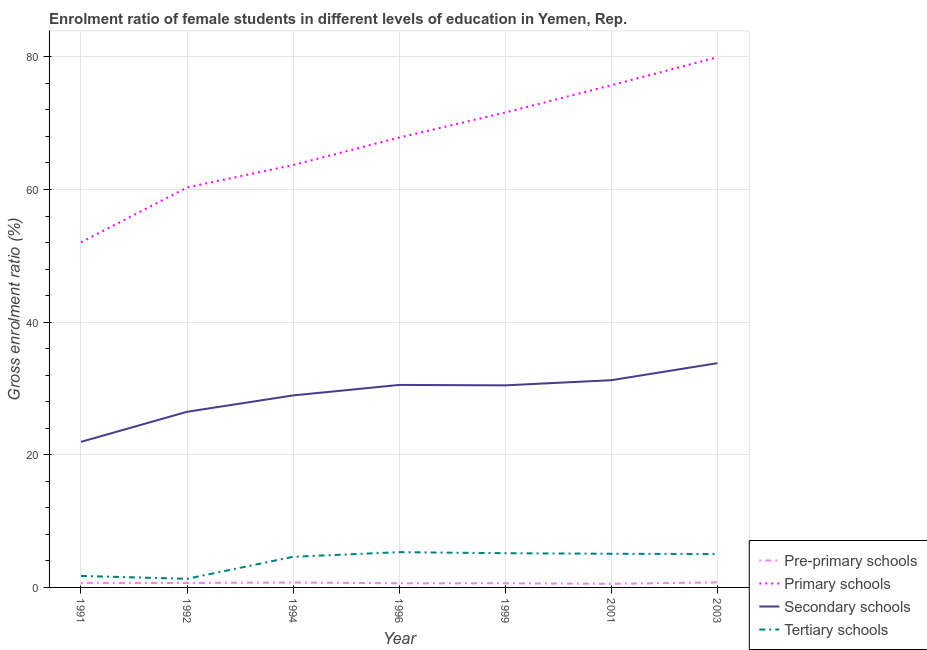Is the number of lines equal to the number of legend labels?
Your answer should be very brief. Yes. What is the gross enrolment ratio(male) in pre-primary schools in 2003?
Ensure brevity in your answer.  0.76. Across all years, what is the maximum gross enrolment ratio(male) in pre-primary schools?
Provide a short and direct response. 0.76. Across all years, what is the minimum gross enrolment ratio(male) in secondary schools?
Offer a terse response. 21.95. In which year was the gross enrolment ratio(male) in secondary schools maximum?
Give a very brief answer. 2003. What is the total gross enrolment ratio(male) in secondary schools in the graph?
Ensure brevity in your answer.  203.45. What is the difference between the gross enrolment ratio(male) in primary schools in 1999 and that in 2001?
Make the answer very short. -4.11. What is the difference between the gross enrolment ratio(male) in tertiary schools in 1999 and the gross enrolment ratio(male) in pre-primary schools in 1996?
Provide a succinct answer. 4.54. What is the average gross enrolment ratio(male) in secondary schools per year?
Offer a terse response. 29.06. In the year 2003, what is the difference between the gross enrolment ratio(male) in pre-primary schools and gross enrolment ratio(male) in primary schools?
Your answer should be compact. -79.19. In how many years, is the gross enrolment ratio(male) in pre-primary schools greater than 20 %?
Your answer should be very brief. 0. What is the ratio of the gross enrolment ratio(male) in tertiary schools in 1992 to that in 1999?
Give a very brief answer. 0.25. Is the difference between the gross enrolment ratio(male) in primary schools in 1996 and 2003 greater than the difference between the gross enrolment ratio(male) in secondary schools in 1996 and 2003?
Provide a succinct answer. No. What is the difference between the highest and the second highest gross enrolment ratio(male) in pre-primary schools?
Your response must be concise. 0.02. What is the difference between the highest and the lowest gross enrolment ratio(male) in tertiary schools?
Offer a very short reply. 4.02. Is the sum of the gross enrolment ratio(male) in pre-primary schools in 2001 and 2003 greater than the maximum gross enrolment ratio(male) in primary schools across all years?
Make the answer very short. No. Is it the case that in every year, the sum of the gross enrolment ratio(male) in secondary schools and gross enrolment ratio(male) in tertiary schools is greater than the sum of gross enrolment ratio(male) in primary schools and gross enrolment ratio(male) in pre-primary schools?
Give a very brief answer. No. Is it the case that in every year, the sum of the gross enrolment ratio(male) in pre-primary schools and gross enrolment ratio(male) in primary schools is greater than the gross enrolment ratio(male) in secondary schools?
Provide a succinct answer. Yes. Is the gross enrolment ratio(male) in primary schools strictly greater than the gross enrolment ratio(male) in secondary schools over the years?
Your response must be concise. Yes. Is the gross enrolment ratio(male) in tertiary schools strictly less than the gross enrolment ratio(male) in pre-primary schools over the years?
Your answer should be compact. No. What is the difference between two consecutive major ticks on the Y-axis?
Make the answer very short. 20. Does the graph contain any zero values?
Make the answer very short. No. Does the graph contain grids?
Offer a very short reply. Yes. Where does the legend appear in the graph?
Your answer should be very brief. Bottom right. How many legend labels are there?
Your answer should be compact. 4. How are the legend labels stacked?
Your answer should be very brief. Vertical. What is the title of the graph?
Make the answer very short. Enrolment ratio of female students in different levels of education in Yemen, Rep. What is the label or title of the X-axis?
Ensure brevity in your answer.  Year. What is the label or title of the Y-axis?
Provide a succinct answer. Gross enrolment ratio (%). What is the Gross enrolment ratio (%) in Pre-primary schools in 1991?
Offer a terse response. 0.68. What is the Gross enrolment ratio (%) in Primary schools in 1991?
Offer a terse response. 52.03. What is the Gross enrolment ratio (%) in Secondary schools in 1991?
Your response must be concise. 21.95. What is the Gross enrolment ratio (%) of Tertiary schools in 1991?
Your response must be concise. 1.73. What is the Gross enrolment ratio (%) in Pre-primary schools in 1992?
Give a very brief answer. 0.67. What is the Gross enrolment ratio (%) in Primary schools in 1992?
Provide a succinct answer. 60.31. What is the Gross enrolment ratio (%) in Secondary schools in 1992?
Keep it short and to the point. 26.48. What is the Gross enrolment ratio (%) of Tertiary schools in 1992?
Offer a very short reply. 1.3. What is the Gross enrolment ratio (%) of Pre-primary schools in 1994?
Offer a terse response. 0.74. What is the Gross enrolment ratio (%) of Primary schools in 1994?
Your answer should be compact. 63.69. What is the Gross enrolment ratio (%) of Secondary schools in 1994?
Your response must be concise. 28.95. What is the Gross enrolment ratio (%) in Tertiary schools in 1994?
Ensure brevity in your answer.  4.62. What is the Gross enrolment ratio (%) of Pre-primary schools in 1996?
Ensure brevity in your answer.  0.62. What is the Gross enrolment ratio (%) of Primary schools in 1996?
Your answer should be compact. 67.84. What is the Gross enrolment ratio (%) in Secondary schools in 1996?
Your response must be concise. 30.53. What is the Gross enrolment ratio (%) of Tertiary schools in 1996?
Offer a terse response. 5.32. What is the Gross enrolment ratio (%) of Pre-primary schools in 1999?
Keep it short and to the point. 0.63. What is the Gross enrolment ratio (%) in Primary schools in 1999?
Make the answer very short. 71.61. What is the Gross enrolment ratio (%) in Secondary schools in 1999?
Provide a succinct answer. 30.47. What is the Gross enrolment ratio (%) of Tertiary schools in 1999?
Ensure brevity in your answer.  5.16. What is the Gross enrolment ratio (%) of Pre-primary schools in 2001?
Offer a terse response. 0.55. What is the Gross enrolment ratio (%) of Primary schools in 2001?
Give a very brief answer. 75.72. What is the Gross enrolment ratio (%) of Secondary schools in 2001?
Give a very brief answer. 31.25. What is the Gross enrolment ratio (%) in Tertiary schools in 2001?
Your answer should be very brief. 5.07. What is the Gross enrolment ratio (%) of Pre-primary schools in 2003?
Provide a succinct answer. 0.76. What is the Gross enrolment ratio (%) of Primary schools in 2003?
Give a very brief answer. 79.96. What is the Gross enrolment ratio (%) of Secondary schools in 2003?
Provide a short and direct response. 33.82. What is the Gross enrolment ratio (%) of Tertiary schools in 2003?
Ensure brevity in your answer.  5.03. Across all years, what is the maximum Gross enrolment ratio (%) of Pre-primary schools?
Offer a very short reply. 0.76. Across all years, what is the maximum Gross enrolment ratio (%) in Primary schools?
Your answer should be compact. 79.96. Across all years, what is the maximum Gross enrolment ratio (%) of Secondary schools?
Your response must be concise. 33.82. Across all years, what is the maximum Gross enrolment ratio (%) in Tertiary schools?
Provide a short and direct response. 5.32. Across all years, what is the minimum Gross enrolment ratio (%) of Pre-primary schools?
Your answer should be very brief. 0.55. Across all years, what is the minimum Gross enrolment ratio (%) in Primary schools?
Your answer should be very brief. 52.03. Across all years, what is the minimum Gross enrolment ratio (%) of Secondary schools?
Your answer should be very brief. 21.95. Across all years, what is the minimum Gross enrolment ratio (%) of Tertiary schools?
Provide a short and direct response. 1.3. What is the total Gross enrolment ratio (%) of Pre-primary schools in the graph?
Make the answer very short. 4.66. What is the total Gross enrolment ratio (%) of Primary schools in the graph?
Make the answer very short. 471.15. What is the total Gross enrolment ratio (%) of Secondary schools in the graph?
Keep it short and to the point. 203.45. What is the total Gross enrolment ratio (%) in Tertiary schools in the graph?
Your answer should be compact. 28.24. What is the difference between the Gross enrolment ratio (%) in Pre-primary schools in 1991 and that in 1992?
Offer a terse response. 0.01. What is the difference between the Gross enrolment ratio (%) in Primary schools in 1991 and that in 1992?
Your response must be concise. -8.28. What is the difference between the Gross enrolment ratio (%) of Secondary schools in 1991 and that in 1992?
Offer a very short reply. -4.54. What is the difference between the Gross enrolment ratio (%) in Tertiary schools in 1991 and that in 1992?
Your answer should be very brief. 0.43. What is the difference between the Gross enrolment ratio (%) in Pre-primary schools in 1991 and that in 1994?
Make the answer very short. -0.06. What is the difference between the Gross enrolment ratio (%) in Primary schools in 1991 and that in 1994?
Keep it short and to the point. -11.65. What is the difference between the Gross enrolment ratio (%) in Secondary schools in 1991 and that in 1994?
Make the answer very short. -7. What is the difference between the Gross enrolment ratio (%) of Tertiary schools in 1991 and that in 1994?
Provide a short and direct response. -2.89. What is the difference between the Gross enrolment ratio (%) in Pre-primary schools in 1991 and that in 1996?
Keep it short and to the point. 0.06. What is the difference between the Gross enrolment ratio (%) of Primary schools in 1991 and that in 1996?
Your answer should be very brief. -15.8. What is the difference between the Gross enrolment ratio (%) in Secondary schools in 1991 and that in 1996?
Provide a short and direct response. -8.59. What is the difference between the Gross enrolment ratio (%) in Tertiary schools in 1991 and that in 1996?
Provide a short and direct response. -3.59. What is the difference between the Gross enrolment ratio (%) of Pre-primary schools in 1991 and that in 1999?
Offer a very short reply. 0.05. What is the difference between the Gross enrolment ratio (%) of Primary schools in 1991 and that in 1999?
Give a very brief answer. -19.57. What is the difference between the Gross enrolment ratio (%) of Secondary schools in 1991 and that in 1999?
Give a very brief answer. -8.52. What is the difference between the Gross enrolment ratio (%) in Tertiary schools in 1991 and that in 1999?
Make the answer very short. -3.43. What is the difference between the Gross enrolment ratio (%) in Pre-primary schools in 1991 and that in 2001?
Offer a terse response. 0.14. What is the difference between the Gross enrolment ratio (%) of Primary schools in 1991 and that in 2001?
Provide a succinct answer. -23.69. What is the difference between the Gross enrolment ratio (%) in Secondary schools in 1991 and that in 2001?
Offer a very short reply. -9.3. What is the difference between the Gross enrolment ratio (%) in Tertiary schools in 1991 and that in 2001?
Offer a very short reply. -3.34. What is the difference between the Gross enrolment ratio (%) of Pre-primary schools in 1991 and that in 2003?
Ensure brevity in your answer.  -0.08. What is the difference between the Gross enrolment ratio (%) of Primary schools in 1991 and that in 2003?
Keep it short and to the point. -27.92. What is the difference between the Gross enrolment ratio (%) in Secondary schools in 1991 and that in 2003?
Your response must be concise. -11.87. What is the difference between the Gross enrolment ratio (%) in Tertiary schools in 1991 and that in 2003?
Offer a very short reply. -3.3. What is the difference between the Gross enrolment ratio (%) of Pre-primary schools in 1992 and that in 1994?
Provide a short and direct response. -0.07. What is the difference between the Gross enrolment ratio (%) in Primary schools in 1992 and that in 1994?
Keep it short and to the point. -3.38. What is the difference between the Gross enrolment ratio (%) in Secondary schools in 1992 and that in 1994?
Ensure brevity in your answer.  -2.47. What is the difference between the Gross enrolment ratio (%) of Tertiary schools in 1992 and that in 1994?
Your answer should be compact. -3.32. What is the difference between the Gross enrolment ratio (%) of Pre-primary schools in 1992 and that in 1996?
Your answer should be compact. 0.05. What is the difference between the Gross enrolment ratio (%) in Primary schools in 1992 and that in 1996?
Offer a terse response. -7.53. What is the difference between the Gross enrolment ratio (%) in Secondary schools in 1992 and that in 1996?
Your answer should be very brief. -4.05. What is the difference between the Gross enrolment ratio (%) in Tertiary schools in 1992 and that in 1996?
Your answer should be very brief. -4.02. What is the difference between the Gross enrolment ratio (%) in Pre-primary schools in 1992 and that in 1999?
Give a very brief answer. 0.04. What is the difference between the Gross enrolment ratio (%) in Primary schools in 1992 and that in 1999?
Keep it short and to the point. -11.3. What is the difference between the Gross enrolment ratio (%) of Secondary schools in 1992 and that in 1999?
Your response must be concise. -3.99. What is the difference between the Gross enrolment ratio (%) of Tertiary schools in 1992 and that in 1999?
Make the answer very short. -3.86. What is the difference between the Gross enrolment ratio (%) of Pre-primary schools in 1992 and that in 2001?
Offer a very short reply. 0.13. What is the difference between the Gross enrolment ratio (%) of Primary schools in 1992 and that in 2001?
Give a very brief answer. -15.41. What is the difference between the Gross enrolment ratio (%) in Secondary schools in 1992 and that in 2001?
Your answer should be very brief. -4.76. What is the difference between the Gross enrolment ratio (%) of Tertiary schools in 1992 and that in 2001?
Ensure brevity in your answer.  -3.78. What is the difference between the Gross enrolment ratio (%) of Pre-primary schools in 1992 and that in 2003?
Your response must be concise. -0.09. What is the difference between the Gross enrolment ratio (%) of Primary schools in 1992 and that in 2003?
Provide a succinct answer. -19.65. What is the difference between the Gross enrolment ratio (%) of Secondary schools in 1992 and that in 2003?
Provide a short and direct response. -7.33. What is the difference between the Gross enrolment ratio (%) in Tertiary schools in 1992 and that in 2003?
Offer a terse response. -3.74. What is the difference between the Gross enrolment ratio (%) of Pre-primary schools in 1994 and that in 1996?
Provide a succinct answer. 0.12. What is the difference between the Gross enrolment ratio (%) of Primary schools in 1994 and that in 1996?
Offer a terse response. -4.15. What is the difference between the Gross enrolment ratio (%) of Secondary schools in 1994 and that in 1996?
Make the answer very short. -1.58. What is the difference between the Gross enrolment ratio (%) in Tertiary schools in 1994 and that in 1996?
Provide a succinct answer. -0.7. What is the difference between the Gross enrolment ratio (%) of Pre-primary schools in 1994 and that in 1999?
Offer a terse response. 0.11. What is the difference between the Gross enrolment ratio (%) in Primary schools in 1994 and that in 1999?
Provide a short and direct response. -7.92. What is the difference between the Gross enrolment ratio (%) of Secondary schools in 1994 and that in 1999?
Provide a succinct answer. -1.52. What is the difference between the Gross enrolment ratio (%) in Tertiary schools in 1994 and that in 1999?
Keep it short and to the point. -0.54. What is the difference between the Gross enrolment ratio (%) in Pre-primary schools in 1994 and that in 2001?
Ensure brevity in your answer.  0.2. What is the difference between the Gross enrolment ratio (%) of Primary schools in 1994 and that in 2001?
Keep it short and to the point. -12.03. What is the difference between the Gross enrolment ratio (%) in Secondary schools in 1994 and that in 2001?
Make the answer very short. -2.3. What is the difference between the Gross enrolment ratio (%) of Tertiary schools in 1994 and that in 2001?
Offer a very short reply. -0.46. What is the difference between the Gross enrolment ratio (%) of Pre-primary schools in 1994 and that in 2003?
Your answer should be very brief. -0.02. What is the difference between the Gross enrolment ratio (%) in Primary schools in 1994 and that in 2003?
Offer a terse response. -16.27. What is the difference between the Gross enrolment ratio (%) of Secondary schools in 1994 and that in 2003?
Your answer should be very brief. -4.86. What is the difference between the Gross enrolment ratio (%) of Tertiary schools in 1994 and that in 2003?
Your response must be concise. -0.42. What is the difference between the Gross enrolment ratio (%) in Pre-primary schools in 1996 and that in 1999?
Keep it short and to the point. -0.01. What is the difference between the Gross enrolment ratio (%) in Primary schools in 1996 and that in 1999?
Your response must be concise. -3.77. What is the difference between the Gross enrolment ratio (%) of Secondary schools in 1996 and that in 1999?
Your response must be concise. 0.06. What is the difference between the Gross enrolment ratio (%) of Tertiary schools in 1996 and that in 1999?
Offer a very short reply. 0.16. What is the difference between the Gross enrolment ratio (%) of Pre-primary schools in 1996 and that in 2001?
Offer a terse response. 0.08. What is the difference between the Gross enrolment ratio (%) of Primary schools in 1996 and that in 2001?
Your answer should be very brief. -7.89. What is the difference between the Gross enrolment ratio (%) in Secondary schools in 1996 and that in 2001?
Give a very brief answer. -0.72. What is the difference between the Gross enrolment ratio (%) of Tertiary schools in 1996 and that in 2001?
Offer a terse response. 0.25. What is the difference between the Gross enrolment ratio (%) in Pre-primary schools in 1996 and that in 2003?
Your answer should be very brief. -0.14. What is the difference between the Gross enrolment ratio (%) in Primary schools in 1996 and that in 2003?
Your answer should be compact. -12.12. What is the difference between the Gross enrolment ratio (%) in Secondary schools in 1996 and that in 2003?
Keep it short and to the point. -3.28. What is the difference between the Gross enrolment ratio (%) in Tertiary schools in 1996 and that in 2003?
Your answer should be very brief. 0.29. What is the difference between the Gross enrolment ratio (%) in Pre-primary schools in 1999 and that in 2001?
Keep it short and to the point. 0.08. What is the difference between the Gross enrolment ratio (%) in Primary schools in 1999 and that in 2001?
Your answer should be very brief. -4.11. What is the difference between the Gross enrolment ratio (%) in Secondary schools in 1999 and that in 2001?
Offer a terse response. -0.78. What is the difference between the Gross enrolment ratio (%) in Tertiary schools in 1999 and that in 2001?
Keep it short and to the point. 0.08. What is the difference between the Gross enrolment ratio (%) of Pre-primary schools in 1999 and that in 2003?
Your answer should be very brief. -0.13. What is the difference between the Gross enrolment ratio (%) in Primary schools in 1999 and that in 2003?
Your response must be concise. -8.35. What is the difference between the Gross enrolment ratio (%) in Secondary schools in 1999 and that in 2003?
Keep it short and to the point. -3.34. What is the difference between the Gross enrolment ratio (%) of Tertiary schools in 1999 and that in 2003?
Provide a succinct answer. 0.12. What is the difference between the Gross enrolment ratio (%) of Pre-primary schools in 2001 and that in 2003?
Keep it short and to the point. -0.22. What is the difference between the Gross enrolment ratio (%) of Primary schools in 2001 and that in 2003?
Your answer should be compact. -4.23. What is the difference between the Gross enrolment ratio (%) in Secondary schools in 2001 and that in 2003?
Offer a terse response. -2.57. What is the difference between the Gross enrolment ratio (%) in Tertiary schools in 2001 and that in 2003?
Your response must be concise. 0.04. What is the difference between the Gross enrolment ratio (%) in Pre-primary schools in 1991 and the Gross enrolment ratio (%) in Primary schools in 1992?
Your answer should be compact. -59.63. What is the difference between the Gross enrolment ratio (%) of Pre-primary schools in 1991 and the Gross enrolment ratio (%) of Secondary schools in 1992?
Offer a terse response. -25.8. What is the difference between the Gross enrolment ratio (%) of Pre-primary schools in 1991 and the Gross enrolment ratio (%) of Tertiary schools in 1992?
Your answer should be very brief. -0.62. What is the difference between the Gross enrolment ratio (%) in Primary schools in 1991 and the Gross enrolment ratio (%) in Secondary schools in 1992?
Your response must be concise. 25.55. What is the difference between the Gross enrolment ratio (%) of Primary schools in 1991 and the Gross enrolment ratio (%) of Tertiary schools in 1992?
Offer a very short reply. 50.73. What is the difference between the Gross enrolment ratio (%) of Secondary schools in 1991 and the Gross enrolment ratio (%) of Tertiary schools in 1992?
Give a very brief answer. 20.65. What is the difference between the Gross enrolment ratio (%) in Pre-primary schools in 1991 and the Gross enrolment ratio (%) in Primary schools in 1994?
Your response must be concise. -63. What is the difference between the Gross enrolment ratio (%) in Pre-primary schools in 1991 and the Gross enrolment ratio (%) in Secondary schools in 1994?
Your answer should be very brief. -28.27. What is the difference between the Gross enrolment ratio (%) in Pre-primary schools in 1991 and the Gross enrolment ratio (%) in Tertiary schools in 1994?
Offer a very short reply. -3.94. What is the difference between the Gross enrolment ratio (%) in Primary schools in 1991 and the Gross enrolment ratio (%) in Secondary schools in 1994?
Offer a very short reply. 23.08. What is the difference between the Gross enrolment ratio (%) in Primary schools in 1991 and the Gross enrolment ratio (%) in Tertiary schools in 1994?
Provide a succinct answer. 47.41. What is the difference between the Gross enrolment ratio (%) of Secondary schools in 1991 and the Gross enrolment ratio (%) of Tertiary schools in 1994?
Your answer should be compact. 17.33. What is the difference between the Gross enrolment ratio (%) of Pre-primary schools in 1991 and the Gross enrolment ratio (%) of Primary schools in 1996?
Provide a short and direct response. -67.15. What is the difference between the Gross enrolment ratio (%) of Pre-primary schools in 1991 and the Gross enrolment ratio (%) of Secondary schools in 1996?
Your answer should be very brief. -29.85. What is the difference between the Gross enrolment ratio (%) in Pre-primary schools in 1991 and the Gross enrolment ratio (%) in Tertiary schools in 1996?
Offer a very short reply. -4.64. What is the difference between the Gross enrolment ratio (%) of Primary schools in 1991 and the Gross enrolment ratio (%) of Secondary schools in 1996?
Give a very brief answer. 21.5. What is the difference between the Gross enrolment ratio (%) in Primary schools in 1991 and the Gross enrolment ratio (%) in Tertiary schools in 1996?
Make the answer very short. 46.71. What is the difference between the Gross enrolment ratio (%) of Secondary schools in 1991 and the Gross enrolment ratio (%) of Tertiary schools in 1996?
Provide a short and direct response. 16.63. What is the difference between the Gross enrolment ratio (%) of Pre-primary schools in 1991 and the Gross enrolment ratio (%) of Primary schools in 1999?
Provide a succinct answer. -70.92. What is the difference between the Gross enrolment ratio (%) in Pre-primary schools in 1991 and the Gross enrolment ratio (%) in Secondary schools in 1999?
Provide a succinct answer. -29.79. What is the difference between the Gross enrolment ratio (%) of Pre-primary schools in 1991 and the Gross enrolment ratio (%) of Tertiary schools in 1999?
Offer a very short reply. -4.47. What is the difference between the Gross enrolment ratio (%) in Primary schools in 1991 and the Gross enrolment ratio (%) in Secondary schools in 1999?
Your answer should be compact. 21.56. What is the difference between the Gross enrolment ratio (%) in Primary schools in 1991 and the Gross enrolment ratio (%) in Tertiary schools in 1999?
Provide a succinct answer. 46.87. What is the difference between the Gross enrolment ratio (%) in Secondary schools in 1991 and the Gross enrolment ratio (%) in Tertiary schools in 1999?
Your response must be concise. 16.79. What is the difference between the Gross enrolment ratio (%) in Pre-primary schools in 1991 and the Gross enrolment ratio (%) in Primary schools in 2001?
Ensure brevity in your answer.  -75.04. What is the difference between the Gross enrolment ratio (%) in Pre-primary schools in 1991 and the Gross enrolment ratio (%) in Secondary schools in 2001?
Give a very brief answer. -30.57. What is the difference between the Gross enrolment ratio (%) in Pre-primary schools in 1991 and the Gross enrolment ratio (%) in Tertiary schools in 2001?
Give a very brief answer. -4.39. What is the difference between the Gross enrolment ratio (%) of Primary schools in 1991 and the Gross enrolment ratio (%) of Secondary schools in 2001?
Ensure brevity in your answer.  20.78. What is the difference between the Gross enrolment ratio (%) in Primary schools in 1991 and the Gross enrolment ratio (%) in Tertiary schools in 2001?
Provide a succinct answer. 46.96. What is the difference between the Gross enrolment ratio (%) of Secondary schools in 1991 and the Gross enrolment ratio (%) of Tertiary schools in 2001?
Your answer should be compact. 16.87. What is the difference between the Gross enrolment ratio (%) of Pre-primary schools in 1991 and the Gross enrolment ratio (%) of Primary schools in 2003?
Keep it short and to the point. -79.27. What is the difference between the Gross enrolment ratio (%) in Pre-primary schools in 1991 and the Gross enrolment ratio (%) in Secondary schools in 2003?
Keep it short and to the point. -33.13. What is the difference between the Gross enrolment ratio (%) of Pre-primary schools in 1991 and the Gross enrolment ratio (%) of Tertiary schools in 2003?
Your answer should be compact. -4.35. What is the difference between the Gross enrolment ratio (%) of Primary schools in 1991 and the Gross enrolment ratio (%) of Secondary schools in 2003?
Offer a very short reply. 18.22. What is the difference between the Gross enrolment ratio (%) of Primary schools in 1991 and the Gross enrolment ratio (%) of Tertiary schools in 2003?
Keep it short and to the point. 47. What is the difference between the Gross enrolment ratio (%) in Secondary schools in 1991 and the Gross enrolment ratio (%) in Tertiary schools in 2003?
Your answer should be very brief. 16.91. What is the difference between the Gross enrolment ratio (%) in Pre-primary schools in 1992 and the Gross enrolment ratio (%) in Primary schools in 1994?
Make the answer very short. -63.02. What is the difference between the Gross enrolment ratio (%) in Pre-primary schools in 1992 and the Gross enrolment ratio (%) in Secondary schools in 1994?
Provide a succinct answer. -28.28. What is the difference between the Gross enrolment ratio (%) of Pre-primary schools in 1992 and the Gross enrolment ratio (%) of Tertiary schools in 1994?
Make the answer very short. -3.95. What is the difference between the Gross enrolment ratio (%) in Primary schools in 1992 and the Gross enrolment ratio (%) in Secondary schools in 1994?
Give a very brief answer. 31.36. What is the difference between the Gross enrolment ratio (%) in Primary schools in 1992 and the Gross enrolment ratio (%) in Tertiary schools in 1994?
Offer a very short reply. 55.69. What is the difference between the Gross enrolment ratio (%) in Secondary schools in 1992 and the Gross enrolment ratio (%) in Tertiary schools in 1994?
Give a very brief answer. 21.87. What is the difference between the Gross enrolment ratio (%) of Pre-primary schools in 1992 and the Gross enrolment ratio (%) of Primary schools in 1996?
Ensure brevity in your answer.  -67.16. What is the difference between the Gross enrolment ratio (%) in Pre-primary schools in 1992 and the Gross enrolment ratio (%) in Secondary schools in 1996?
Keep it short and to the point. -29.86. What is the difference between the Gross enrolment ratio (%) in Pre-primary schools in 1992 and the Gross enrolment ratio (%) in Tertiary schools in 1996?
Give a very brief answer. -4.65. What is the difference between the Gross enrolment ratio (%) of Primary schools in 1992 and the Gross enrolment ratio (%) of Secondary schools in 1996?
Offer a terse response. 29.78. What is the difference between the Gross enrolment ratio (%) of Primary schools in 1992 and the Gross enrolment ratio (%) of Tertiary schools in 1996?
Ensure brevity in your answer.  54.99. What is the difference between the Gross enrolment ratio (%) of Secondary schools in 1992 and the Gross enrolment ratio (%) of Tertiary schools in 1996?
Offer a very short reply. 21.16. What is the difference between the Gross enrolment ratio (%) of Pre-primary schools in 1992 and the Gross enrolment ratio (%) of Primary schools in 1999?
Provide a short and direct response. -70.94. What is the difference between the Gross enrolment ratio (%) in Pre-primary schools in 1992 and the Gross enrolment ratio (%) in Secondary schools in 1999?
Your answer should be very brief. -29.8. What is the difference between the Gross enrolment ratio (%) of Pre-primary schools in 1992 and the Gross enrolment ratio (%) of Tertiary schools in 1999?
Offer a very short reply. -4.49. What is the difference between the Gross enrolment ratio (%) of Primary schools in 1992 and the Gross enrolment ratio (%) of Secondary schools in 1999?
Your response must be concise. 29.84. What is the difference between the Gross enrolment ratio (%) of Primary schools in 1992 and the Gross enrolment ratio (%) of Tertiary schools in 1999?
Keep it short and to the point. 55.15. What is the difference between the Gross enrolment ratio (%) in Secondary schools in 1992 and the Gross enrolment ratio (%) in Tertiary schools in 1999?
Make the answer very short. 21.33. What is the difference between the Gross enrolment ratio (%) of Pre-primary schools in 1992 and the Gross enrolment ratio (%) of Primary schools in 2001?
Keep it short and to the point. -75.05. What is the difference between the Gross enrolment ratio (%) of Pre-primary schools in 1992 and the Gross enrolment ratio (%) of Secondary schools in 2001?
Your answer should be compact. -30.58. What is the difference between the Gross enrolment ratio (%) of Pre-primary schools in 1992 and the Gross enrolment ratio (%) of Tertiary schools in 2001?
Ensure brevity in your answer.  -4.4. What is the difference between the Gross enrolment ratio (%) in Primary schools in 1992 and the Gross enrolment ratio (%) in Secondary schools in 2001?
Offer a very short reply. 29.06. What is the difference between the Gross enrolment ratio (%) of Primary schools in 1992 and the Gross enrolment ratio (%) of Tertiary schools in 2001?
Offer a very short reply. 55.23. What is the difference between the Gross enrolment ratio (%) of Secondary schools in 1992 and the Gross enrolment ratio (%) of Tertiary schools in 2001?
Give a very brief answer. 21.41. What is the difference between the Gross enrolment ratio (%) in Pre-primary schools in 1992 and the Gross enrolment ratio (%) in Primary schools in 2003?
Your answer should be very brief. -79.28. What is the difference between the Gross enrolment ratio (%) of Pre-primary schools in 1992 and the Gross enrolment ratio (%) of Secondary schools in 2003?
Provide a short and direct response. -33.14. What is the difference between the Gross enrolment ratio (%) of Pre-primary schools in 1992 and the Gross enrolment ratio (%) of Tertiary schools in 2003?
Your answer should be compact. -4.36. What is the difference between the Gross enrolment ratio (%) of Primary schools in 1992 and the Gross enrolment ratio (%) of Secondary schools in 2003?
Offer a very short reply. 26.49. What is the difference between the Gross enrolment ratio (%) of Primary schools in 1992 and the Gross enrolment ratio (%) of Tertiary schools in 2003?
Give a very brief answer. 55.27. What is the difference between the Gross enrolment ratio (%) in Secondary schools in 1992 and the Gross enrolment ratio (%) in Tertiary schools in 2003?
Make the answer very short. 21.45. What is the difference between the Gross enrolment ratio (%) in Pre-primary schools in 1994 and the Gross enrolment ratio (%) in Primary schools in 1996?
Keep it short and to the point. -67.09. What is the difference between the Gross enrolment ratio (%) of Pre-primary schools in 1994 and the Gross enrolment ratio (%) of Secondary schools in 1996?
Offer a terse response. -29.79. What is the difference between the Gross enrolment ratio (%) of Pre-primary schools in 1994 and the Gross enrolment ratio (%) of Tertiary schools in 1996?
Offer a very short reply. -4.58. What is the difference between the Gross enrolment ratio (%) of Primary schools in 1994 and the Gross enrolment ratio (%) of Secondary schools in 1996?
Your answer should be compact. 33.15. What is the difference between the Gross enrolment ratio (%) in Primary schools in 1994 and the Gross enrolment ratio (%) in Tertiary schools in 1996?
Your answer should be very brief. 58.37. What is the difference between the Gross enrolment ratio (%) of Secondary schools in 1994 and the Gross enrolment ratio (%) of Tertiary schools in 1996?
Make the answer very short. 23.63. What is the difference between the Gross enrolment ratio (%) of Pre-primary schools in 1994 and the Gross enrolment ratio (%) of Primary schools in 1999?
Offer a terse response. -70.86. What is the difference between the Gross enrolment ratio (%) in Pre-primary schools in 1994 and the Gross enrolment ratio (%) in Secondary schools in 1999?
Your response must be concise. -29.73. What is the difference between the Gross enrolment ratio (%) of Pre-primary schools in 1994 and the Gross enrolment ratio (%) of Tertiary schools in 1999?
Provide a short and direct response. -4.41. What is the difference between the Gross enrolment ratio (%) of Primary schools in 1994 and the Gross enrolment ratio (%) of Secondary schools in 1999?
Provide a succinct answer. 33.22. What is the difference between the Gross enrolment ratio (%) in Primary schools in 1994 and the Gross enrolment ratio (%) in Tertiary schools in 1999?
Give a very brief answer. 58.53. What is the difference between the Gross enrolment ratio (%) in Secondary schools in 1994 and the Gross enrolment ratio (%) in Tertiary schools in 1999?
Provide a short and direct response. 23.79. What is the difference between the Gross enrolment ratio (%) in Pre-primary schools in 1994 and the Gross enrolment ratio (%) in Primary schools in 2001?
Keep it short and to the point. -74.98. What is the difference between the Gross enrolment ratio (%) of Pre-primary schools in 1994 and the Gross enrolment ratio (%) of Secondary schools in 2001?
Make the answer very short. -30.51. What is the difference between the Gross enrolment ratio (%) in Pre-primary schools in 1994 and the Gross enrolment ratio (%) in Tertiary schools in 2001?
Ensure brevity in your answer.  -4.33. What is the difference between the Gross enrolment ratio (%) in Primary schools in 1994 and the Gross enrolment ratio (%) in Secondary schools in 2001?
Provide a short and direct response. 32.44. What is the difference between the Gross enrolment ratio (%) in Primary schools in 1994 and the Gross enrolment ratio (%) in Tertiary schools in 2001?
Keep it short and to the point. 58.61. What is the difference between the Gross enrolment ratio (%) of Secondary schools in 1994 and the Gross enrolment ratio (%) of Tertiary schools in 2001?
Your answer should be very brief. 23.88. What is the difference between the Gross enrolment ratio (%) in Pre-primary schools in 1994 and the Gross enrolment ratio (%) in Primary schools in 2003?
Provide a succinct answer. -79.21. What is the difference between the Gross enrolment ratio (%) of Pre-primary schools in 1994 and the Gross enrolment ratio (%) of Secondary schools in 2003?
Provide a succinct answer. -33.07. What is the difference between the Gross enrolment ratio (%) in Pre-primary schools in 1994 and the Gross enrolment ratio (%) in Tertiary schools in 2003?
Ensure brevity in your answer.  -4.29. What is the difference between the Gross enrolment ratio (%) of Primary schools in 1994 and the Gross enrolment ratio (%) of Secondary schools in 2003?
Give a very brief answer. 29.87. What is the difference between the Gross enrolment ratio (%) of Primary schools in 1994 and the Gross enrolment ratio (%) of Tertiary schools in 2003?
Offer a terse response. 58.65. What is the difference between the Gross enrolment ratio (%) of Secondary schools in 1994 and the Gross enrolment ratio (%) of Tertiary schools in 2003?
Your response must be concise. 23.92. What is the difference between the Gross enrolment ratio (%) in Pre-primary schools in 1996 and the Gross enrolment ratio (%) in Primary schools in 1999?
Your response must be concise. -70.99. What is the difference between the Gross enrolment ratio (%) of Pre-primary schools in 1996 and the Gross enrolment ratio (%) of Secondary schools in 1999?
Your answer should be compact. -29.85. What is the difference between the Gross enrolment ratio (%) of Pre-primary schools in 1996 and the Gross enrolment ratio (%) of Tertiary schools in 1999?
Your answer should be very brief. -4.54. What is the difference between the Gross enrolment ratio (%) of Primary schools in 1996 and the Gross enrolment ratio (%) of Secondary schools in 1999?
Give a very brief answer. 37.37. What is the difference between the Gross enrolment ratio (%) in Primary schools in 1996 and the Gross enrolment ratio (%) in Tertiary schools in 1999?
Make the answer very short. 62.68. What is the difference between the Gross enrolment ratio (%) of Secondary schools in 1996 and the Gross enrolment ratio (%) of Tertiary schools in 1999?
Give a very brief answer. 25.38. What is the difference between the Gross enrolment ratio (%) in Pre-primary schools in 1996 and the Gross enrolment ratio (%) in Primary schools in 2001?
Your response must be concise. -75.1. What is the difference between the Gross enrolment ratio (%) of Pre-primary schools in 1996 and the Gross enrolment ratio (%) of Secondary schools in 2001?
Make the answer very short. -30.63. What is the difference between the Gross enrolment ratio (%) of Pre-primary schools in 1996 and the Gross enrolment ratio (%) of Tertiary schools in 2001?
Give a very brief answer. -4.45. What is the difference between the Gross enrolment ratio (%) in Primary schools in 1996 and the Gross enrolment ratio (%) in Secondary schools in 2001?
Offer a very short reply. 36.59. What is the difference between the Gross enrolment ratio (%) in Primary schools in 1996 and the Gross enrolment ratio (%) in Tertiary schools in 2001?
Provide a succinct answer. 62.76. What is the difference between the Gross enrolment ratio (%) of Secondary schools in 1996 and the Gross enrolment ratio (%) of Tertiary schools in 2001?
Provide a succinct answer. 25.46. What is the difference between the Gross enrolment ratio (%) of Pre-primary schools in 1996 and the Gross enrolment ratio (%) of Primary schools in 2003?
Keep it short and to the point. -79.33. What is the difference between the Gross enrolment ratio (%) in Pre-primary schools in 1996 and the Gross enrolment ratio (%) in Secondary schools in 2003?
Your answer should be compact. -33.19. What is the difference between the Gross enrolment ratio (%) in Pre-primary schools in 1996 and the Gross enrolment ratio (%) in Tertiary schools in 2003?
Make the answer very short. -4.41. What is the difference between the Gross enrolment ratio (%) in Primary schools in 1996 and the Gross enrolment ratio (%) in Secondary schools in 2003?
Provide a succinct answer. 34.02. What is the difference between the Gross enrolment ratio (%) of Primary schools in 1996 and the Gross enrolment ratio (%) of Tertiary schools in 2003?
Ensure brevity in your answer.  62.8. What is the difference between the Gross enrolment ratio (%) in Secondary schools in 1996 and the Gross enrolment ratio (%) in Tertiary schools in 2003?
Your answer should be compact. 25.5. What is the difference between the Gross enrolment ratio (%) in Pre-primary schools in 1999 and the Gross enrolment ratio (%) in Primary schools in 2001?
Offer a very short reply. -75.09. What is the difference between the Gross enrolment ratio (%) of Pre-primary schools in 1999 and the Gross enrolment ratio (%) of Secondary schools in 2001?
Give a very brief answer. -30.62. What is the difference between the Gross enrolment ratio (%) in Pre-primary schools in 1999 and the Gross enrolment ratio (%) in Tertiary schools in 2001?
Provide a succinct answer. -4.44. What is the difference between the Gross enrolment ratio (%) in Primary schools in 1999 and the Gross enrolment ratio (%) in Secondary schools in 2001?
Offer a very short reply. 40.36. What is the difference between the Gross enrolment ratio (%) of Primary schools in 1999 and the Gross enrolment ratio (%) of Tertiary schools in 2001?
Offer a terse response. 66.53. What is the difference between the Gross enrolment ratio (%) in Secondary schools in 1999 and the Gross enrolment ratio (%) in Tertiary schools in 2001?
Offer a very short reply. 25.4. What is the difference between the Gross enrolment ratio (%) of Pre-primary schools in 1999 and the Gross enrolment ratio (%) of Primary schools in 2003?
Offer a very short reply. -79.33. What is the difference between the Gross enrolment ratio (%) in Pre-primary schools in 1999 and the Gross enrolment ratio (%) in Secondary schools in 2003?
Your answer should be very brief. -33.18. What is the difference between the Gross enrolment ratio (%) in Pre-primary schools in 1999 and the Gross enrolment ratio (%) in Tertiary schools in 2003?
Your response must be concise. -4.4. What is the difference between the Gross enrolment ratio (%) of Primary schools in 1999 and the Gross enrolment ratio (%) of Secondary schools in 2003?
Offer a terse response. 37.79. What is the difference between the Gross enrolment ratio (%) in Primary schools in 1999 and the Gross enrolment ratio (%) in Tertiary schools in 2003?
Provide a succinct answer. 66.57. What is the difference between the Gross enrolment ratio (%) in Secondary schools in 1999 and the Gross enrolment ratio (%) in Tertiary schools in 2003?
Offer a terse response. 25.44. What is the difference between the Gross enrolment ratio (%) in Pre-primary schools in 2001 and the Gross enrolment ratio (%) in Primary schools in 2003?
Your answer should be compact. -79.41. What is the difference between the Gross enrolment ratio (%) of Pre-primary schools in 2001 and the Gross enrolment ratio (%) of Secondary schools in 2003?
Your answer should be very brief. -33.27. What is the difference between the Gross enrolment ratio (%) of Pre-primary schools in 2001 and the Gross enrolment ratio (%) of Tertiary schools in 2003?
Your response must be concise. -4.49. What is the difference between the Gross enrolment ratio (%) in Primary schools in 2001 and the Gross enrolment ratio (%) in Secondary schools in 2003?
Keep it short and to the point. 41.91. What is the difference between the Gross enrolment ratio (%) of Primary schools in 2001 and the Gross enrolment ratio (%) of Tertiary schools in 2003?
Your answer should be compact. 70.69. What is the difference between the Gross enrolment ratio (%) in Secondary schools in 2001 and the Gross enrolment ratio (%) in Tertiary schools in 2003?
Keep it short and to the point. 26.21. What is the average Gross enrolment ratio (%) in Pre-primary schools per year?
Provide a succinct answer. 0.67. What is the average Gross enrolment ratio (%) in Primary schools per year?
Ensure brevity in your answer.  67.31. What is the average Gross enrolment ratio (%) in Secondary schools per year?
Ensure brevity in your answer.  29.06. What is the average Gross enrolment ratio (%) in Tertiary schools per year?
Offer a terse response. 4.03. In the year 1991, what is the difference between the Gross enrolment ratio (%) of Pre-primary schools and Gross enrolment ratio (%) of Primary schools?
Keep it short and to the point. -51.35. In the year 1991, what is the difference between the Gross enrolment ratio (%) in Pre-primary schools and Gross enrolment ratio (%) in Secondary schools?
Offer a very short reply. -21.27. In the year 1991, what is the difference between the Gross enrolment ratio (%) in Pre-primary schools and Gross enrolment ratio (%) in Tertiary schools?
Make the answer very short. -1.05. In the year 1991, what is the difference between the Gross enrolment ratio (%) in Primary schools and Gross enrolment ratio (%) in Secondary schools?
Provide a succinct answer. 30.08. In the year 1991, what is the difference between the Gross enrolment ratio (%) of Primary schools and Gross enrolment ratio (%) of Tertiary schools?
Make the answer very short. 50.3. In the year 1991, what is the difference between the Gross enrolment ratio (%) in Secondary schools and Gross enrolment ratio (%) in Tertiary schools?
Your answer should be compact. 20.22. In the year 1992, what is the difference between the Gross enrolment ratio (%) in Pre-primary schools and Gross enrolment ratio (%) in Primary schools?
Offer a terse response. -59.64. In the year 1992, what is the difference between the Gross enrolment ratio (%) of Pre-primary schools and Gross enrolment ratio (%) of Secondary schools?
Offer a terse response. -25.81. In the year 1992, what is the difference between the Gross enrolment ratio (%) in Pre-primary schools and Gross enrolment ratio (%) in Tertiary schools?
Provide a succinct answer. -0.63. In the year 1992, what is the difference between the Gross enrolment ratio (%) of Primary schools and Gross enrolment ratio (%) of Secondary schools?
Keep it short and to the point. 33.82. In the year 1992, what is the difference between the Gross enrolment ratio (%) in Primary schools and Gross enrolment ratio (%) in Tertiary schools?
Your answer should be compact. 59.01. In the year 1992, what is the difference between the Gross enrolment ratio (%) in Secondary schools and Gross enrolment ratio (%) in Tertiary schools?
Ensure brevity in your answer.  25.19. In the year 1994, what is the difference between the Gross enrolment ratio (%) of Pre-primary schools and Gross enrolment ratio (%) of Primary schools?
Ensure brevity in your answer.  -62.94. In the year 1994, what is the difference between the Gross enrolment ratio (%) of Pre-primary schools and Gross enrolment ratio (%) of Secondary schools?
Provide a succinct answer. -28.21. In the year 1994, what is the difference between the Gross enrolment ratio (%) of Pre-primary schools and Gross enrolment ratio (%) of Tertiary schools?
Offer a terse response. -3.88. In the year 1994, what is the difference between the Gross enrolment ratio (%) of Primary schools and Gross enrolment ratio (%) of Secondary schools?
Ensure brevity in your answer.  34.73. In the year 1994, what is the difference between the Gross enrolment ratio (%) of Primary schools and Gross enrolment ratio (%) of Tertiary schools?
Offer a very short reply. 59.07. In the year 1994, what is the difference between the Gross enrolment ratio (%) of Secondary schools and Gross enrolment ratio (%) of Tertiary schools?
Give a very brief answer. 24.33. In the year 1996, what is the difference between the Gross enrolment ratio (%) of Pre-primary schools and Gross enrolment ratio (%) of Primary schools?
Provide a succinct answer. -67.21. In the year 1996, what is the difference between the Gross enrolment ratio (%) of Pre-primary schools and Gross enrolment ratio (%) of Secondary schools?
Offer a terse response. -29.91. In the year 1996, what is the difference between the Gross enrolment ratio (%) in Pre-primary schools and Gross enrolment ratio (%) in Tertiary schools?
Keep it short and to the point. -4.7. In the year 1996, what is the difference between the Gross enrolment ratio (%) in Primary schools and Gross enrolment ratio (%) in Secondary schools?
Provide a succinct answer. 37.3. In the year 1996, what is the difference between the Gross enrolment ratio (%) in Primary schools and Gross enrolment ratio (%) in Tertiary schools?
Provide a succinct answer. 62.52. In the year 1996, what is the difference between the Gross enrolment ratio (%) of Secondary schools and Gross enrolment ratio (%) of Tertiary schools?
Your answer should be compact. 25.21. In the year 1999, what is the difference between the Gross enrolment ratio (%) of Pre-primary schools and Gross enrolment ratio (%) of Primary schools?
Ensure brevity in your answer.  -70.98. In the year 1999, what is the difference between the Gross enrolment ratio (%) of Pre-primary schools and Gross enrolment ratio (%) of Secondary schools?
Ensure brevity in your answer.  -29.84. In the year 1999, what is the difference between the Gross enrolment ratio (%) in Pre-primary schools and Gross enrolment ratio (%) in Tertiary schools?
Provide a succinct answer. -4.53. In the year 1999, what is the difference between the Gross enrolment ratio (%) in Primary schools and Gross enrolment ratio (%) in Secondary schools?
Provide a succinct answer. 41.14. In the year 1999, what is the difference between the Gross enrolment ratio (%) of Primary schools and Gross enrolment ratio (%) of Tertiary schools?
Your response must be concise. 66.45. In the year 1999, what is the difference between the Gross enrolment ratio (%) in Secondary schools and Gross enrolment ratio (%) in Tertiary schools?
Your answer should be very brief. 25.31. In the year 2001, what is the difference between the Gross enrolment ratio (%) in Pre-primary schools and Gross enrolment ratio (%) in Primary schools?
Make the answer very short. -75.18. In the year 2001, what is the difference between the Gross enrolment ratio (%) of Pre-primary schools and Gross enrolment ratio (%) of Secondary schools?
Your answer should be compact. -30.7. In the year 2001, what is the difference between the Gross enrolment ratio (%) in Pre-primary schools and Gross enrolment ratio (%) in Tertiary schools?
Your answer should be very brief. -4.53. In the year 2001, what is the difference between the Gross enrolment ratio (%) of Primary schools and Gross enrolment ratio (%) of Secondary schools?
Offer a terse response. 44.47. In the year 2001, what is the difference between the Gross enrolment ratio (%) of Primary schools and Gross enrolment ratio (%) of Tertiary schools?
Provide a short and direct response. 70.65. In the year 2001, what is the difference between the Gross enrolment ratio (%) of Secondary schools and Gross enrolment ratio (%) of Tertiary schools?
Provide a succinct answer. 26.17. In the year 2003, what is the difference between the Gross enrolment ratio (%) of Pre-primary schools and Gross enrolment ratio (%) of Primary schools?
Your answer should be compact. -79.19. In the year 2003, what is the difference between the Gross enrolment ratio (%) in Pre-primary schools and Gross enrolment ratio (%) in Secondary schools?
Offer a terse response. -33.05. In the year 2003, what is the difference between the Gross enrolment ratio (%) of Pre-primary schools and Gross enrolment ratio (%) of Tertiary schools?
Offer a very short reply. -4.27. In the year 2003, what is the difference between the Gross enrolment ratio (%) of Primary schools and Gross enrolment ratio (%) of Secondary schools?
Provide a short and direct response. 46.14. In the year 2003, what is the difference between the Gross enrolment ratio (%) in Primary schools and Gross enrolment ratio (%) in Tertiary schools?
Provide a short and direct response. 74.92. In the year 2003, what is the difference between the Gross enrolment ratio (%) in Secondary schools and Gross enrolment ratio (%) in Tertiary schools?
Your answer should be compact. 28.78. What is the ratio of the Gross enrolment ratio (%) of Pre-primary schools in 1991 to that in 1992?
Offer a terse response. 1.02. What is the ratio of the Gross enrolment ratio (%) of Primary schools in 1991 to that in 1992?
Provide a succinct answer. 0.86. What is the ratio of the Gross enrolment ratio (%) in Secondary schools in 1991 to that in 1992?
Your response must be concise. 0.83. What is the ratio of the Gross enrolment ratio (%) of Pre-primary schools in 1991 to that in 1994?
Offer a very short reply. 0.92. What is the ratio of the Gross enrolment ratio (%) of Primary schools in 1991 to that in 1994?
Offer a terse response. 0.82. What is the ratio of the Gross enrolment ratio (%) of Secondary schools in 1991 to that in 1994?
Give a very brief answer. 0.76. What is the ratio of the Gross enrolment ratio (%) in Tertiary schools in 1991 to that in 1994?
Keep it short and to the point. 0.37. What is the ratio of the Gross enrolment ratio (%) of Pre-primary schools in 1991 to that in 1996?
Your response must be concise. 1.1. What is the ratio of the Gross enrolment ratio (%) in Primary schools in 1991 to that in 1996?
Keep it short and to the point. 0.77. What is the ratio of the Gross enrolment ratio (%) of Secondary schools in 1991 to that in 1996?
Your answer should be compact. 0.72. What is the ratio of the Gross enrolment ratio (%) in Tertiary schools in 1991 to that in 1996?
Make the answer very short. 0.33. What is the ratio of the Gross enrolment ratio (%) of Pre-primary schools in 1991 to that in 1999?
Make the answer very short. 1.08. What is the ratio of the Gross enrolment ratio (%) of Primary schools in 1991 to that in 1999?
Offer a terse response. 0.73. What is the ratio of the Gross enrolment ratio (%) of Secondary schools in 1991 to that in 1999?
Give a very brief answer. 0.72. What is the ratio of the Gross enrolment ratio (%) of Tertiary schools in 1991 to that in 1999?
Keep it short and to the point. 0.34. What is the ratio of the Gross enrolment ratio (%) of Pre-primary schools in 1991 to that in 2001?
Ensure brevity in your answer.  1.25. What is the ratio of the Gross enrolment ratio (%) of Primary schools in 1991 to that in 2001?
Make the answer very short. 0.69. What is the ratio of the Gross enrolment ratio (%) in Secondary schools in 1991 to that in 2001?
Keep it short and to the point. 0.7. What is the ratio of the Gross enrolment ratio (%) of Tertiary schools in 1991 to that in 2001?
Your answer should be very brief. 0.34. What is the ratio of the Gross enrolment ratio (%) of Pre-primary schools in 1991 to that in 2003?
Your answer should be very brief. 0.89. What is the ratio of the Gross enrolment ratio (%) of Primary schools in 1991 to that in 2003?
Keep it short and to the point. 0.65. What is the ratio of the Gross enrolment ratio (%) of Secondary schools in 1991 to that in 2003?
Give a very brief answer. 0.65. What is the ratio of the Gross enrolment ratio (%) in Tertiary schools in 1991 to that in 2003?
Your answer should be very brief. 0.34. What is the ratio of the Gross enrolment ratio (%) in Pre-primary schools in 1992 to that in 1994?
Offer a very short reply. 0.9. What is the ratio of the Gross enrolment ratio (%) of Primary schools in 1992 to that in 1994?
Your response must be concise. 0.95. What is the ratio of the Gross enrolment ratio (%) in Secondary schools in 1992 to that in 1994?
Make the answer very short. 0.91. What is the ratio of the Gross enrolment ratio (%) of Tertiary schools in 1992 to that in 1994?
Offer a terse response. 0.28. What is the ratio of the Gross enrolment ratio (%) in Pre-primary schools in 1992 to that in 1996?
Your answer should be very brief. 1.08. What is the ratio of the Gross enrolment ratio (%) in Primary schools in 1992 to that in 1996?
Ensure brevity in your answer.  0.89. What is the ratio of the Gross enrolment ratio (%) in Secondary schools in 1992 to that in 1996?
Offer a very short reply. 0.87. What is the ratio of the Gross enrolment ratio (%) of Tertiary schools in 1992 to that in 1996?
Your answer should be compact. 0.24. What is the ratio of the Gross enrolment ratio (%) in Pre-primary schools in 1992 to that in 1999?
Your answer should be compact. 1.07. What is the ratio of the Gross enrolment ratio (%) in Primary schools in 1992 to that in 1999?
Provide a succinct answer. 0.84. What is the ratio of the Gross enrolment ratio (%) of Secondary schools in 1992 to that in 1999?
Offer a very short reply. 0.87. What is the ratio of the Gross enrolment ratio (%) in Tertiary schools in 1992 to that in 1999?
Provide a short and direct response. 0.25. What is the ratio of the Gross enrolment ratio (%) in Pre-primary schools in 1992 to that in 2001?
Your response must be concise. 1.23. What is the ratio of the Gross enrolment ratio (%) in Primary schools in 1992 to that in 2001?
Provide a succinct answer. 0.8. What is the ratio of the Gross enrolment ratio (%) of Secondary schools in 1992 to that in 2001?
Offer a terse response. 0.85. What is the ratio of the Gross enrolment ratio (%) in Tertiary schools in 1992 to that in 2001?
Give a very brief answer. 0.26. What is the ratio of the Gross enrolment ratio (%) in Pre-primary schools in 1992 to that in 2003?
Offer a very short reply. 0.88. What is the ratio of the Gross enrolment ratio (%) of Primary schools in 1992 to that in 2003?
Your answer should be compact. 0.75. What is the ratio of the Gross enrolment ratio (%) of Secondary schools in 1992 to that in 2003?
Offer a very short reply. 0.78. What is the ratio of the Gross enrolment ratio (%) in Tertiary schools in 1992 to that in 2003?
Offer a terse response. 0.26. What is the ratio of the Gross enrolment ratio (%) of Pre-primary schools in 1994 to that in 1996?
Offer a terse response. 1.2. What is the ratio of the Gross enrolment ratio (%) in Primary schools in 1994 to that in 1996?
Your answer should be compact. 0.94. What is the ratio of the Gross enrolment ratio (%) in Secondary schools in 1994 to that in 1996?
Your answer should be compact. 0.95. What is the ratio of the Gross enrolment ratio (%) in Tertiary schools in 1994 to that in 1996?
Offer a terse response. 0.87. What is the ratio of the Gross enrolment ratio (%) of Pre-primary schools in 1994 to that in 1999?
Ensure brevity in your answer.  1.18. What is the ratio of the Gross enrolment ratio (%) in Primary schools in 1994 to that in 1999?
Make the answer very short. 0.89. What is the ratio of the Gross enrolment ratio (%) of Secondary schools in 1994 to that in 1999?
Your response must be concise. 0.95. What is the ratio of the Gross enrolment ratio (%) in Tertiary schools in 1994 to that in 1999?
Your answer should be very brief. 0.9. What is the ratio of the Gross enrolment ratio (%) in Pre-primary schools in 1994 to that in 2001?
Provide a short and direct response. 1.36. What is the ratio of the Gross enrolment ratio (%) of Primary schools in 1994 to that in 2001?
Your answer should be very brief. 0.84. What is the ratio of the Gross enrolment ratio (%) in Secondary schools in 1994 to that in 2001?
Offer a terse response. 0.93. What is the ratio of the Gross enrolment ratio (%) in Tertiary schools in 1994 to that in 2001?
Provide a short and direct response. 0.91. What is the ratio of the Gross enrolment ratio (%) of Pre-primary schools in 1994 to that in 2003?
Keep it short and to the point. 0.97. What is the ratio of the Gross enrolment ratio (%) of Primary schools in 1994 to that in 2003?
Your answer should be compact. 0.8. What is the ratio of the Gross enrolment ratio (%) of Secondary schools in 1994 to that in 2003?
Your response must be concise. 0.86. What is the ratio of the Gross enrolment ratio (%) of Tertiary schools in 1994 to that in 2003?
Keep it short and to the point. 0.92. What is the ratio of the Gross enrolment ratio (%) in Primary schools in 1996 to that in 1999?
Make the answer very short. 0.95. What is the ratio of the Gross enrolment ratio (%) of Secondary schools in 1996 to that in 1999?
Provide a succinct answer. 1. What is the ratio of the Gross enrolment ratio (%) of Tertiary schools in 1996 to that in 1999?
Keep it short and to the point. 1.03. What is the ratio of the Gross enrolment ratio (%) in Pre-primary schools in 1996 to that in 2001?
Your answer should be compact. 1.14. What is the ratio of the Gross enrolment ratio (%) in Primary schools in 1996 to that in 2001?
Offer a terse response. 0.9. What is the ratio of the Gross enrolment ratio (%) in Secondary schools in 1996 to that in 2001?
Your answer should be compact. 0.98. What is the ratio of the Gross enrolment ratio (%) in Tertiary schools in 1996 to that in 2001?
Give a very brief answer. 1.05. What is the ratio of the Gross enrolment ratio (%) in Pre-primary schools in 1996 to that in 2003?
Provide a succinct answer. 0.81. What is the ratio of the Gross enrolment ratio (%) of Primary schools in 1996 to that in 2003?
Provide a succinct answer. 0.85. What is the ratio of the Gross enrolment ratio (%) of Secondary schools in 1996 to that in 2003?
Offer a terse response. 0.9. What is the ratio of the Gross enrolment ratio (%) of Tertiary schools in 1996 to that in 2003?
Ensure brevity in your answer.  1.06. What is the ratio of the Gross enrolment ratio (%) in Pre-primary schools in 1999 to that in 2001?
Your response must be concise. 1.15. What is the ratio of the Gross enrolment ratio (%) of Primary schools in 1999 to that in 2001?
Your response must be concise. 0.95. What is the ratio of the Gross enrolment ratio (%) in Secondary schools in 1999 to that in 2001?
Keep it short and to the point. 0.98. What is the ratio of the Gross enrolment ratio (%) in Tertiary schools in 1999 to that in 2001?
Offer a very short reply. 1.02. What is the ratio of the Gross enrolment ratio (%) of Pre-primary schools in 1999 to that in 2003?
Give a very brief answer. 0.82. What is the ratio of the Gross enrolment ratio (%) in Primary schools in 1999 to that in 2003?
Your answer should be very brief. 0.9. What is the ratio of the Gross enrolment ratio (%) in Secondary schools in 1999 to that in 2003?
Provide a succinct answer. 0.9. What is the ratio of the Gross enrolment ratio (%) in Tertiary schools in 1999 to that in 2003?
Offer a terse response. 1.02. What is the ratio of the Gross enrolment ratio (%) in Pre-primary schools in 2001 to that in 2003?
Your answer should be very brief. 0.71. What is the ratio of the Gross enrolment ratio (%) in Primary schools in 2001 to that in 2003?
Your answer should be very brief. 0.95. What is the ratio of the Gross enrolment ratio (%) in Secondary schools in 2001 to that in 2003?
Give a very brief answer. 0.92. What is the ratio of the Gross enrolment ratio (%) in Tertiary schools in 2001 to that in 2003?
Offer a very short reply. 1.01. What is the difference between the highest and the second highest Gross enrolment ratio (%) in Pre-primary schools?
Offer a very short reply. 0.02. What is the difference between the highest and the second highest Gross enrolment ratio (%) of Primary schools?
Your answer should be compact. 4.23. What is the difference between the highest and the second highest Gross enrolment ratio (%) of Secondary schools?
Offer a very short reply. 2.57. What is the difference between the highest and the second highest Gross enrolment ratio (%) in Tertiary schools?
Your answer should be very brief. 0.16. What is the difference between the highest and the lowest Gross enrolment ratio (%) in Pre-primary schools?
Your response must be concise. 0.22. What is the difference between the highest and the lowest Gross enrolment ratio (%) of Primary schools?
Your response must be concise. 27.92. What is the difference between the highest and the lowest Gross enrolment ratio (%) of Secondary schools?
Provide a short and direct response. 11.87. What is the difference between the highest and the lowest Gross enrolment ratio (%) in Tertiary schools?
Keep it short and to the point. 4.02. 